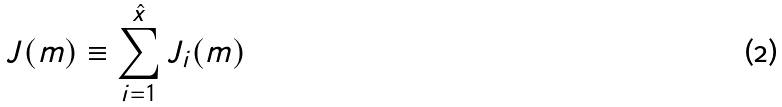Convert formula to latex. <formula><loc_0><loc_0><loc_500><loc_500>J ( m ) \equiv \sum _ { i = 1 } ^ { \hat { x } } J _ { i } ( m )</formula> 